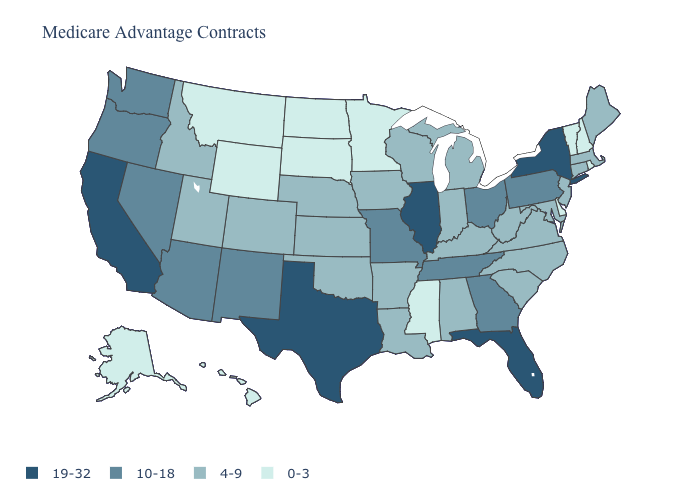Does Kansas have the highest value in the USA?
Give a very brief answer. No. Does Iowa have a higher value than New Hampshire?
Keep it brief. Yes. What is the value of South Dakota?
Answer briefly. 0-3. What is the value of New York?
Quick response, please. 19-32. Does the map have missing data?
Answer briefly. No. Among the states that border Alabama , does Florida have the highest value?
Concise answer only. Yes. Name the states that have a value in the range 19-32?
Answer briefly. California, Florida, Illinois, New York, Texas. How many symbols are there in the legend?
Keep it brief. 4. Which states have the highest value in the USA?
Quick response, please. California, Florida, Illinois, New York, Texas. Which states hav the highest value in the West?
Write a very short answer. California. Which states have the lowest value in the MidWest?
Quick response, please. Minnesota, North Dakota, South Dakota. What is the value of Pennsylvania?
Keep it brief. 10-18. Name the states that have a value in the range 4-9?
Quick response, please. Alabama, Arkansas, Colorado, Connecticut, Iowa, Idaho, Indiana, Kansas, Kentucky, Louisiana, Massachusetts, Maryland, Maine, Michigan, North Carolina, Nebraska, New Jersey, Oklahoma, South Carolina, Utah, Virginia, Wisconsin, West Virginia. Which states have the highest value in the USA?
Keep it brief. California, Florida, Illinois, New York, Texas. Name the states that have a value in the range 19-32?
Be succinct. California, Florida, Illinois, New York, Texas. 